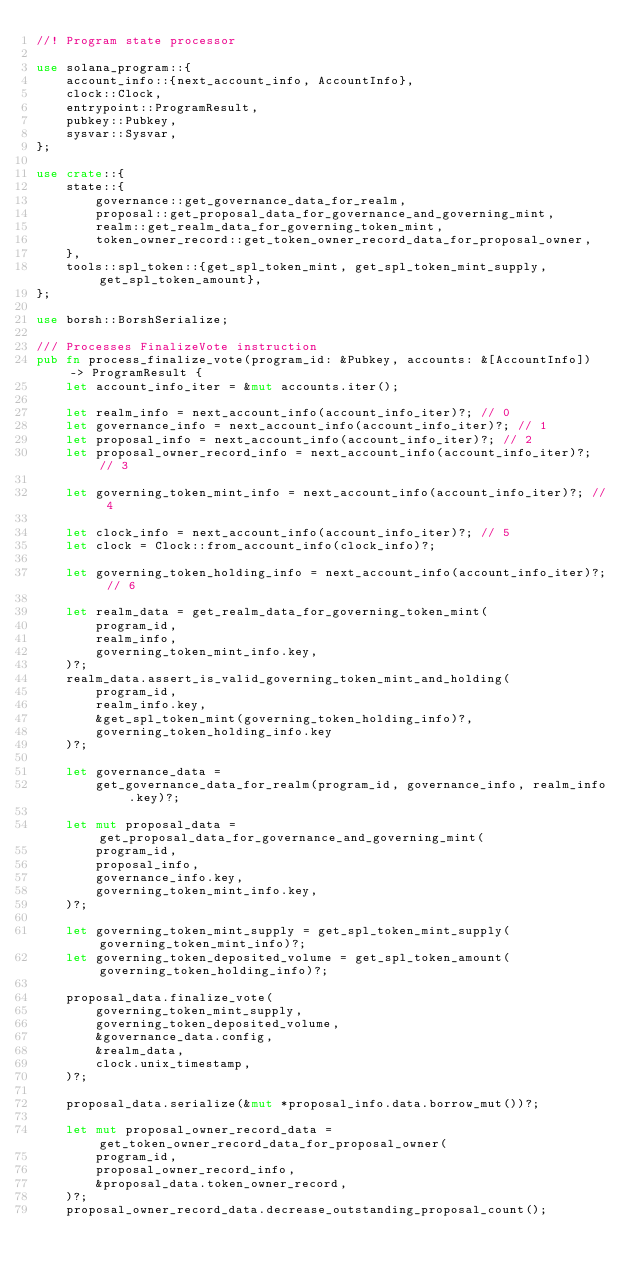Convert code to text. <code><loc_0><loc_0><loc_500><loc_500><_Rust_>//! Program state processor

use solana_program::{
    account_info::{next_account_info, AccountInfo},
    clock::Clock,
    entrypoint::ProgramResult,
    pubkey::Pubkey,
    sysvar::Sysvar,
};

use crate::{
    state::{
        governance::get_governance_data_for_realm,
        proposal::get_proposal_data_for_governance_and_governing_mint,
        realm::get_realm_data_for_governing_token_mint,
        token_owner_record::get_token_owner_record_data_for_proposal_owner,
    },
    tools::spl_token::{get_spl_token_mint, get_spl_token_mint_supply, get_spl_token_amount},
};

use borsh::BorshSerialize;

/// Processes FinalizeVote instruction
pub fn process_finalize_vote(program_id: &Pubkey, accounts: &[AccountInfo]) -> ProgramResult {
    let account_info_iter = &mut accounts.iter();

    let realm_info = next_account_info(account_info_iter)?; // 0
    let governance_info = next_account_info(account_info_iter)?; // 1
    let proposal_info = next_account_info(account_info_iter)?; // 2
    let proposal_owner_record_info = next_account_info(account_info_iter)?; // 3

    let governing_token_mint_info = next_account_info(account_info_iter)?; // 4

    let clock_info = next_account_info(account_info_iter)?; // 5
    let clock = Clock::from_account_info(clock_info)?;

    let governing_token_holding_info = next_account_info(account_info_iter)?; // 6

    let realm_data = get_realm_data_for_governing_token_mint(
        program_id,
        realm_info,
        governing_token_mint_info.key,
    )?;
    realm_data.assert_is_valid_governing_token_mint_and_holding(
        program_id,
        realm_info.key,
        &get_spl_token_mint(governing_token_holding_info)?,
        governing_token_holding_info.key
    )?;

    let governance_data =
        get_governance_data_for_realm(program_id, governance_info, realm_info.key)?;

    let mut proposal_data = get_proposal_data_for_governance_and_governing_mint(
        program_id,
        proposal_info,
        governance_info.key,
        governing_token_mint_info.key,
    )?;

    let governing_token_mint_supply = get_spl_token_mint_supply(governing_token_mint_info)?;
    let governing_token_deposited_volume = get_spl_token_amount(governing_token_holding_info)?;

    proposal_data.finalize_vote(
        governing_token_mint_supply,
        governing_token_deposited_volume,
        &governance_data.config,
        &realm_data,
        clock.unix_timestamp,
    )?;

    proposal_data.serialize(&mut *proposal_info.data.borrow_mut())?;

    let mut proposal_owner_record_data = get_token_owner_record_data_for_proposal_owner(
        program_id,
        proposal_owner_record_info,
        &proposal_data.token_owner_record,
    )?;
    proposal_owner_record_data.decrease_outstanding_proposal_count();</code> 